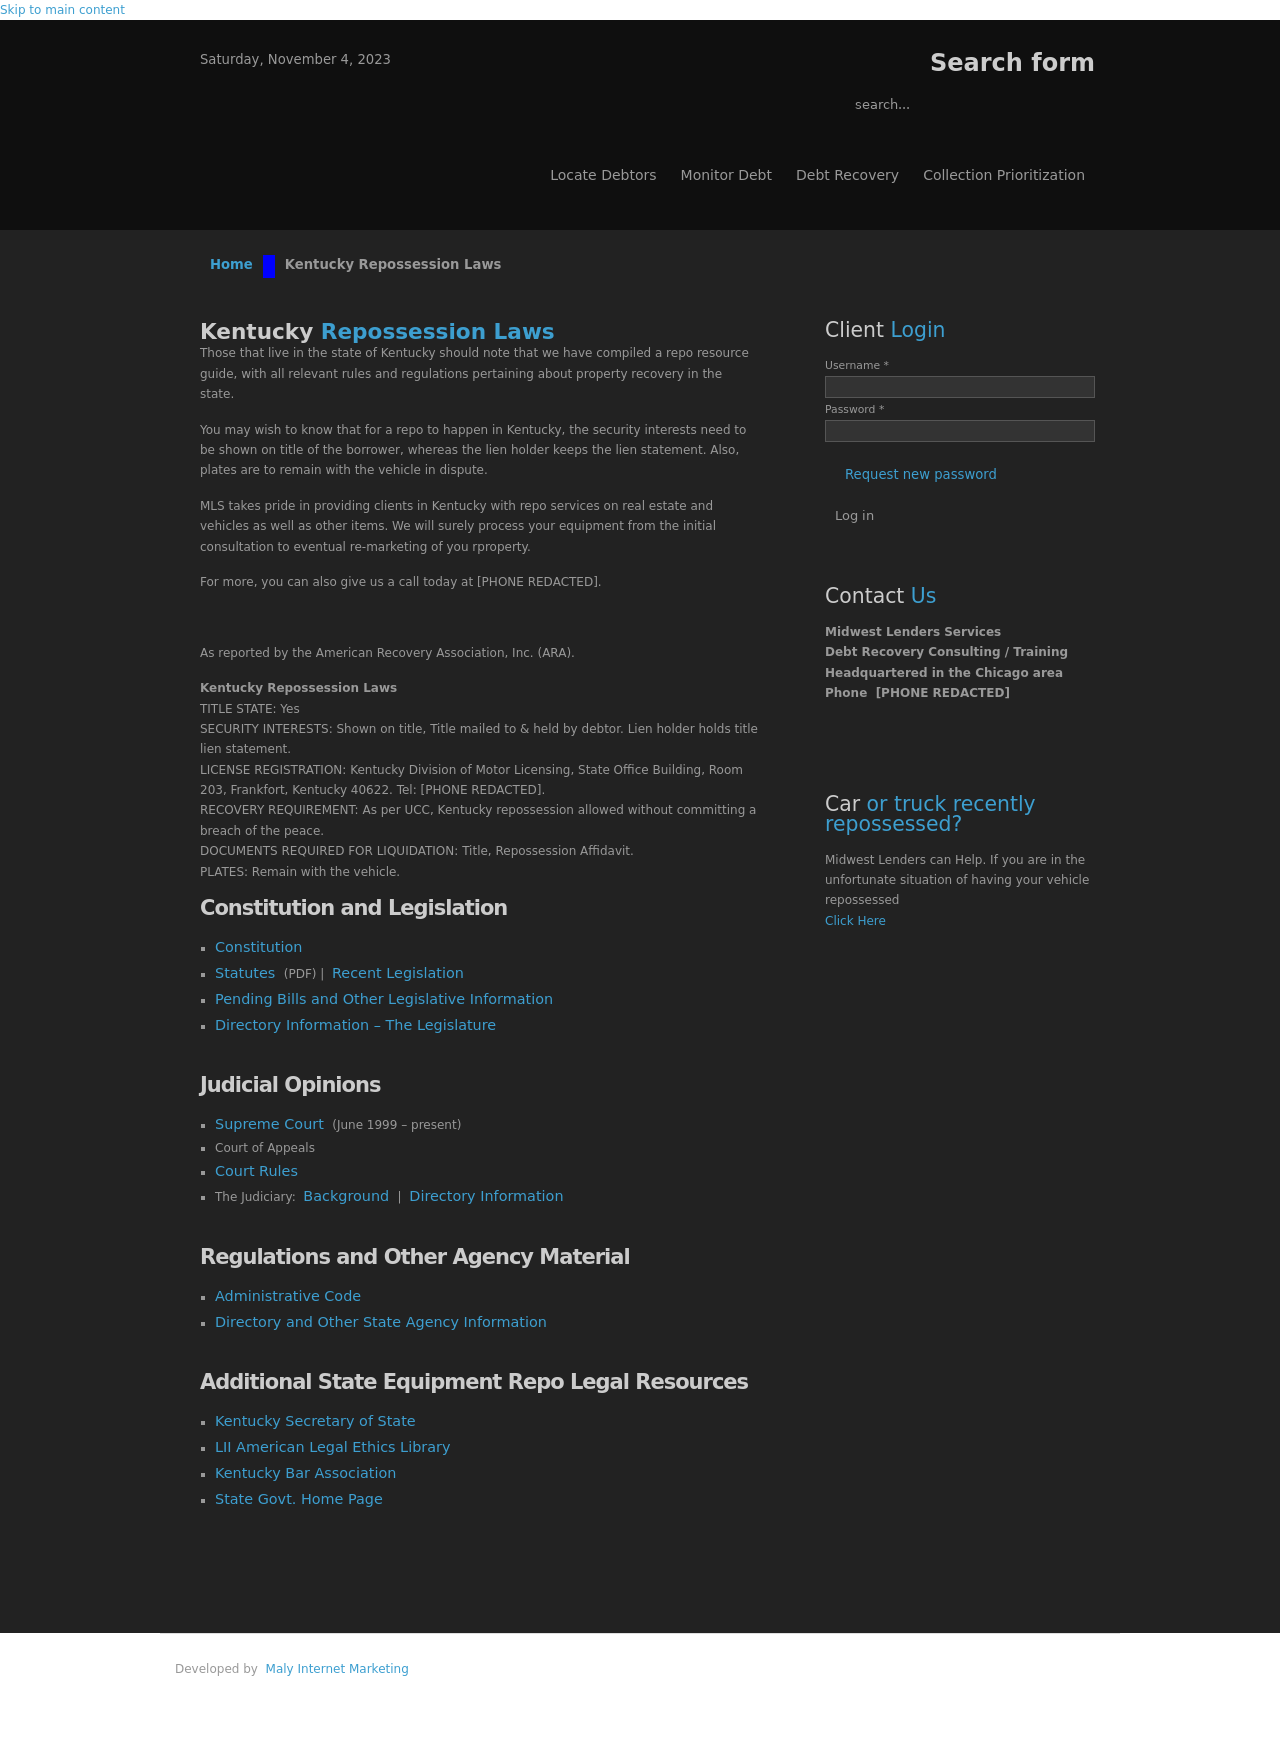Can you explain how the 'Client Login' function is typically integrated on a website like the one shown? Absolutely! The 'Client Login' section usually involves a form with username and password fields. It's typically handled using front-end HTML and CSS for layout, and back-end languages like PHP or JavaScript for session handling and authentication against a database where user credentials are stored. Security is paramount, ensuring data is encrypted and safely transmitted. 